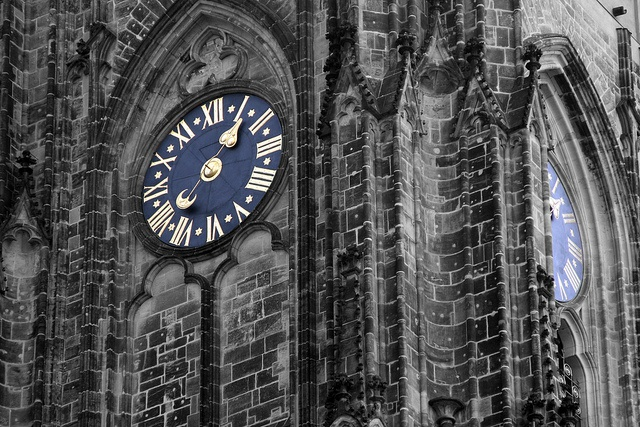Describe the objects in this image and their specific colors. I can see clock in black, gray, darkblue, ivory, and navy tones and clock in black, darkgray, lightgray, and gray tones in this image. 